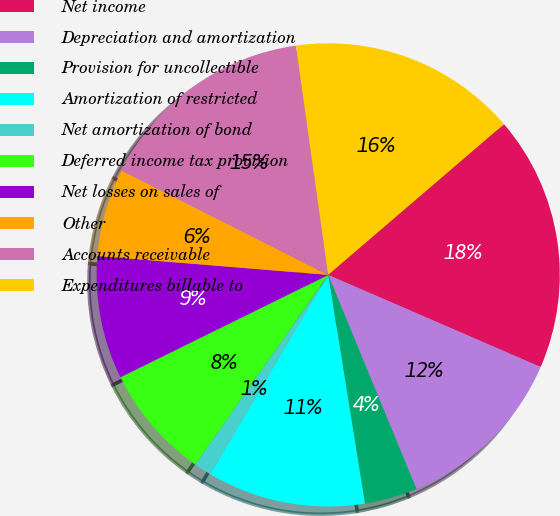Convert chart to OTSL. <chart><loc_0><loc_0><loc_500><loc_500><pie_chart><fcel>Net income<fcel>Depreciation and amortization<fcel>Provision for uncollectible<fcel>Amortization of restricted<fcel>Net amortization of bond<fcel>Deferred income tax provision<fcel>Net losses on sales of<fcel>Other<fcel>Accounts receivable<fcel>Expenditures billable to<nl><fcel>17.79%<fcel>12.27%<fcel>3.69%<fcel>11.04%<fcel>1.23%<fcel>7.98%<fcel>8.59%<fcel>6.14%<fcel>15.33%<fcel>15.95%<nl></chart> 